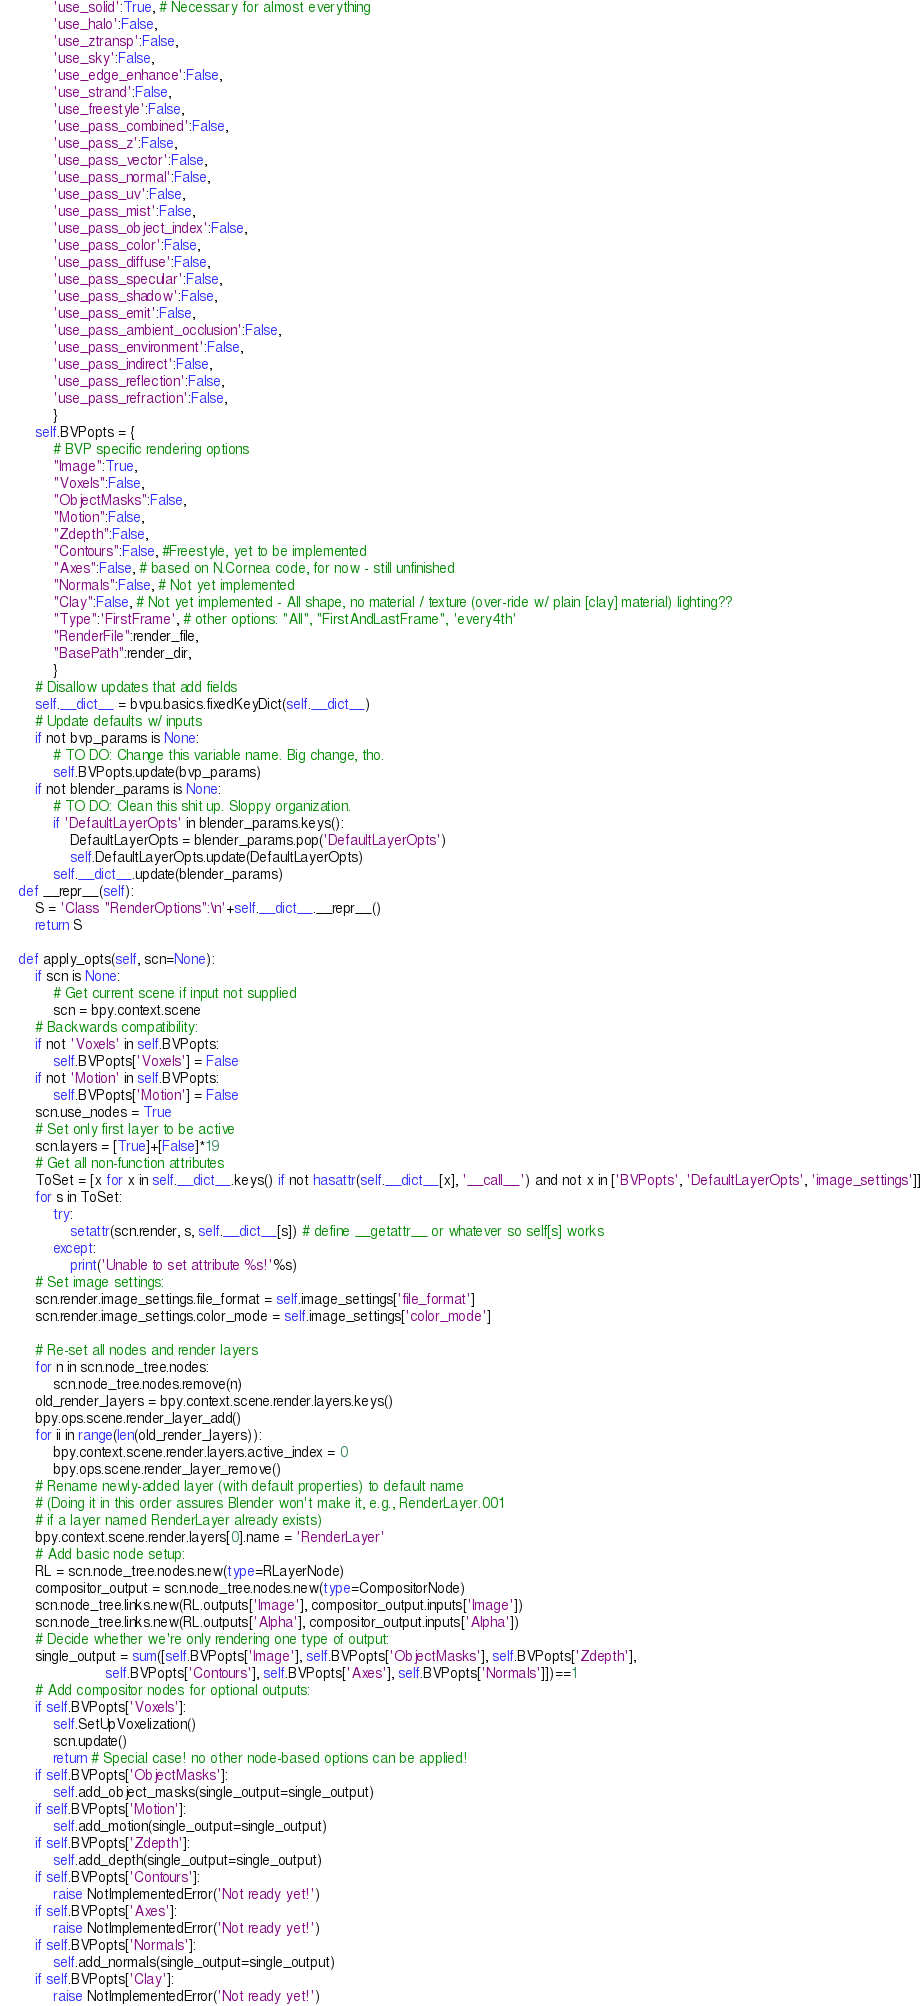<code> <loc_0><loc_0><loc_500><loc_500><_Python_>            'use_solid':True, # Necessary for almost everything
            'use_halo':False, 
            'use_ztransp':False, 
            'use_sky':False, 
            'use_edge_enhance':False, 
            'use_strand':False, 
            'use_freestyle':False, 
            'use_pass_combined':False, 
            'use_pass_z':False, 
            'use_pass_vector':False, 
            'use_pass_normal':False, 
            'use_pass_uv':False, 
            'use_pass_mist':False, 
            'use_pass_object_index':False, 
            'use_pass_color':False, 
            'use_pass_diffuse':False, 
            'use_pass_specular':False, 
            'use_pass_shadow':False, 
            'use_pass_emit':False, 
            'use_pass_ambient_occlusion':False, 
            'use_pass_environment':False, 
            'use_pass_indirect':False, 
            'use_pass_reflection':False, 
            'use_pass_refraction':False, 
            }
        self.BVPopts = {
            # BVP specific rendering options
            "Image":True, 
            "Voxels":False, 
            "ObjectMasks":False, 
            "Motion":False, 
            "Zdepth":False, 
            "Contours":False, #Freestyle, yet to be implemented
            "Axes":False, # based on N.Cornea code, for now - still unfinished
            "Normals":False, # Not yet implemented
            "Clay":False, # Not yet implemented - All shape, no material / texture (over-ride w/ plain [clay] material) lighting??
            "Type":'FirstFrame', # other options: "All", "FirstAndLastFrame", 'every4th'
            "RenderFile":render_file, 
            "BasePath":render_dir, 
            }
        # Disallow updates that add fields
        self.__dict__ = bvpu.basics.fixedKeyDict(self.__dict__)
        # Update defaults w/ inputs
        if not bvp_params is None:
            # TO DO: Change this variable name. Big change, tho.
            self.BVPopts.update(bvp_params)
        if not blender_params is None:
            # TO DO: Clean this shit up. Sloppy organization. 
            if 'DefaultLayerOpts' in blender_params.keys():
                DefaultLayerOpts = blender_params.pop('DefaultLayerOpts')
                self.DefaultLayerOpts.update(DefaultLayerOpts)
            self.__dict__.update(blender_params)
    def __repr__(self):
        S = 'Class "RenderOptions":\n'+self.__dict__.__repr__()
        return S
    
    def apply_opts(self, scn=None):
        if scn is None:
            # Get current scene if input not supplied
            scn = bpy.context.scene
        # Backwards compatibility:
        if not 'Voxels' in self.BVPopts:
            self.BVPopts['Voxels'] = False
        if not 'Motion' in self.BVPopts:
            self.BVPopts['Motion'] = False
        scn.use_nodes = True
        # Set only first layer to be active
        scn.layers = [True]+[False]*19
        # Get all non-function attributes
        ToSet = [x for x in self.__dict__.keys() if not hasattr(self.__dict__[x], '__call__') and not x in ['BVPopts', 'DefaultLayerOpts', 'image_settings']]
        for s in ToSet:
            try:
                setattr(scn.render, s, self.__dict__[s]) # define __getattr__ or whatever so self[s] works
            except:
                print('Unable to set attribute %s!'%s)
        # Set image settings:
        scn.render.image_settings.file_format = self.image_settings['file_format']
        scn.render.image_settings.color_mode = self.image_settings['color_mode']

        # Re-set all nodes and render layers
        for n in scn.node_tree.nodes:
            scn.node_tree.nodes.remove(n)
        old_render_layers = bpy.context.scene.render.layers.keys()
        bpy.ops.scene.render_layer_add()
        for ii in range(len(old_render_layers)):
            bpy.context.scene.render.layers.active_index = 0
            bpy.ops.scene.render_layer_remove()
        # Rename newly-added layer (with default properties) to default name
        # (Doing it in this order assures Blender won't make it, e.g., RenderLayer.001
        # if a layer named RenderLayer already exists)
        bpy.context.scene.render.layers[0].name = 'RenderLayer'
        # Add basic node setup:
        RL = scn.node_tree.nodes.new(type=RLayerNode)
        compositor_output = scn.node_tree.nodes.new(type=CompositorNode)
        scn.node_tree.links.new(RL.outputs['Image'], compositor_output.inputs['Image'])
        scn.node_tree.links.new(RL.outputs['Alpha'], compositor_output.inputs['Alpha'])
        # Decide whether we're only rendering one type of output:
        single_output = sum([self.BVPopts['Image'], self.BVPopts['ObjectMasks'], self.BVPopts['Zdepth'], 
                        self.BVPopts['Contours'], self.BVPopts['Axes'], self.BVPopts['Normals']])==1
        # Add compositor nodes for optional outputs:
        if self.BVPopts['Voxels']:
            self.SetUpVoxelization()
            scn.update()
            return # Special case! no other node-based options can be applied!
        if self.BVPopts['ObjectMasks']:
            self.add_object_masks(single_output=single_output)
        if self.BVPopts['Motion']:
            self.add_motion(single_output=single_output)
        if self.BVPopts['Zdepth']:
            self.add_depth(single_output=single_output)
        if self.BVPopts['Contours']:
            raise NotImplementedError('Not ready yet!')
        if self.BVPopts['Axes']:
            raise NotImplementedError('Not ready yet!')
        if self.BVPopts['Normals']:
            self.add_normals(single_output=single_output)
        if self.BVPopts['Clay']:
            raise NotImplementedError('Not ready yet!')</code> 